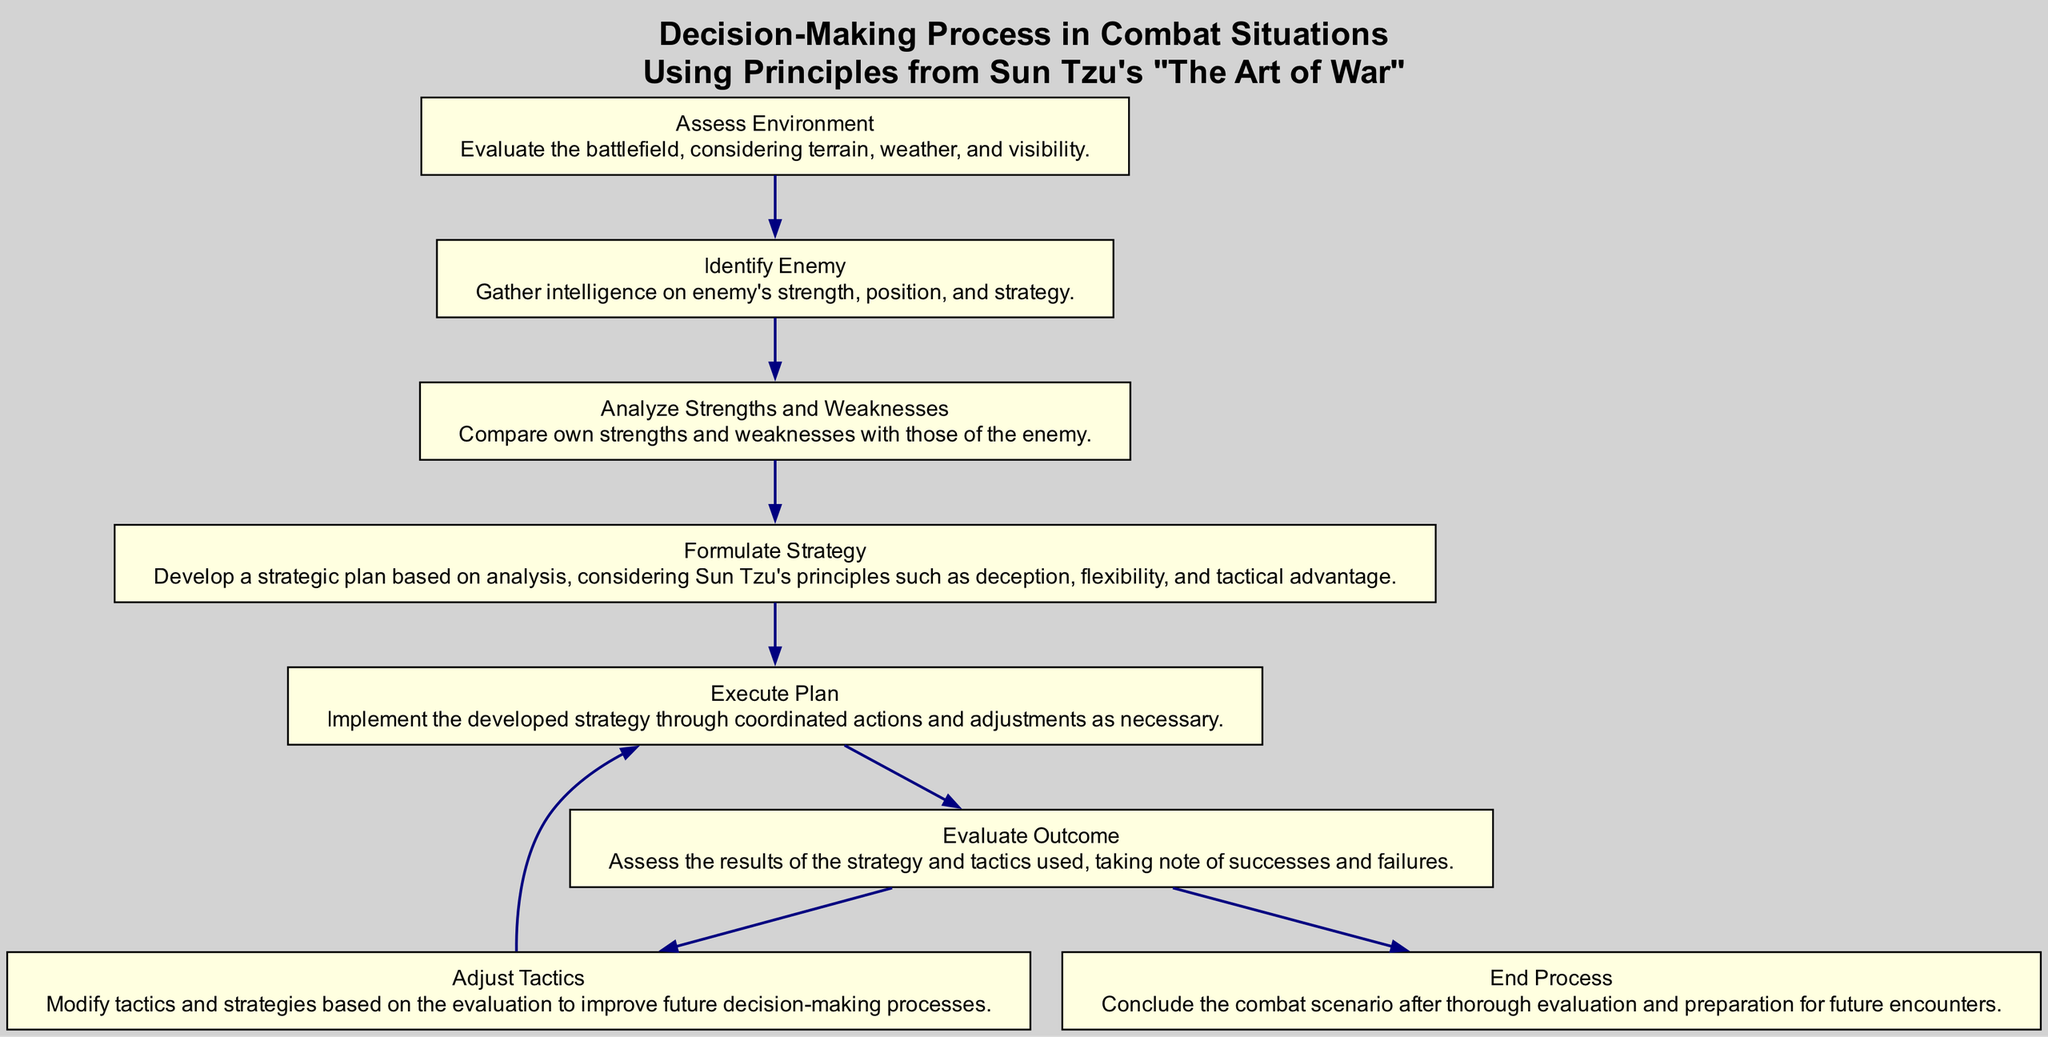What is the first step in the decision-making process? The first step is "Assess Environment." It is the initial action to evaluate the battlefield conditions before taking further actions.
Answer: Assess Environment How many nodes are there in the diagram? Counting each node listed, there are a total of 7 nodes in the diagram.
Answer: 7 What follows after "Formulate Strategy"? The next step after "Formulate Strategy" is "Execute Plan." This shows the continuation of the process after developing a strategy.
Answer: Execute Plan What decision comes after evaluating the outcome? After evaluating the outcome, the options are to "Adjust Tactics" or "End Process," indicating that further adjustments may be needed based on the assessment.
Answer: Adjust Tactics or End Process Is "Analyze Strengths and Weaknesses" connected to "Identify Enemy"? Yes, "Analyze Strengths and Weaknesses" follows directly after "Identify Enemy," establishing a logical progression in the decision-making process.
Answer: Yes If the tactic fails, which step should be revisited? If the tactic fails, one should "Adjust Tactics," which is the necessary step to make modifications based on the outcomes observed.
Answer: Adjust Tactics What is the last action in the decision-making process? The final action in the flow chart is "End Process," indicating the conclusion after thorough evaluation and preparation for future scenarios.
Answer: End Process How does the process begin and what principle does it relate to? The process begins with "Assess Environment," which relates to Sun Tzu's principle of knowing your battlefield, essential for making informed decisions in combat.
Answer: Assess Environment, Sun Tzu's principles What is the relationship between "Execute Plan" and "Evaluate Outcome"? "Execute Plan" leads to "Evaluate Outcome," indicating that after implementing the tactics, it's necessary to assess their effectiveness.
Answer: Execute Plan leads to Evaluate Outcome 